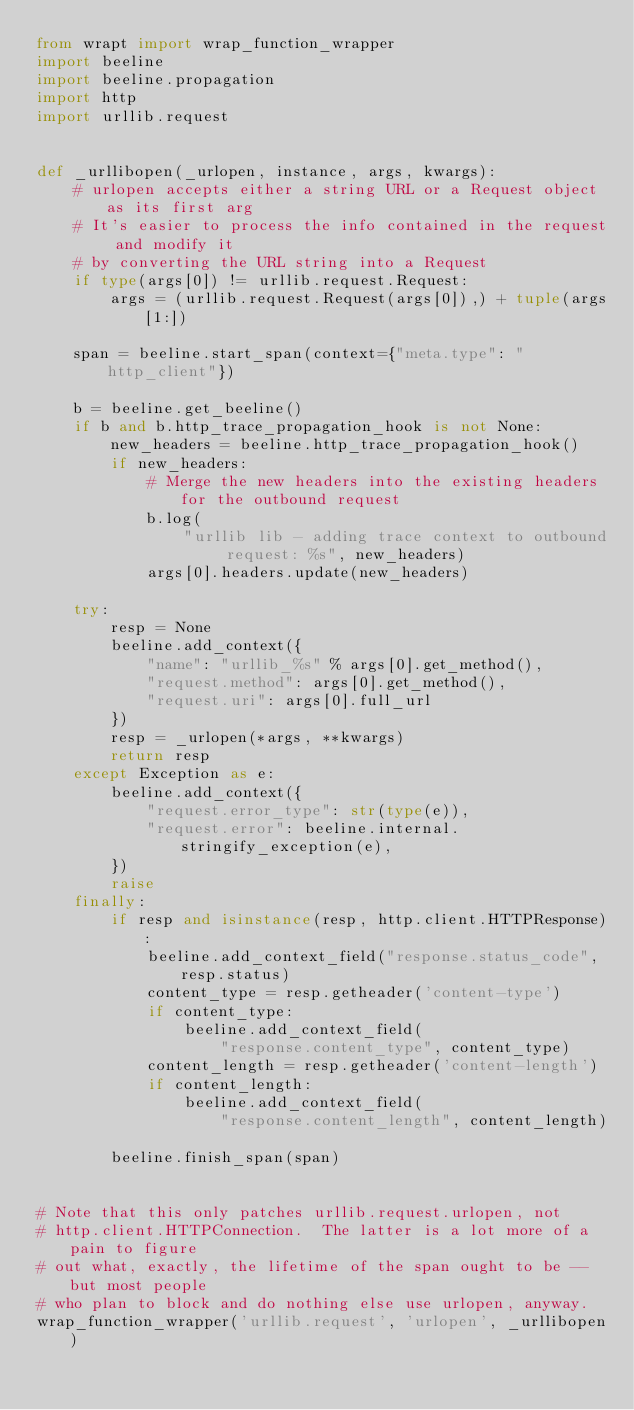Convert code to text. <code><loc_0><loc_0><loc_500><loc_500><_Python_>from wrapt import wrap_function_wrapper
import beeline
import beeline.propagation
import http
import urllib.request


def _urllibopen(_urlopen, instance, args, kwargs):
    # urlopen accepts either a string URL or a Request object as its first arg
    # It's easier to process the info contained in the request and modify it
    # by converting the URL string into a Request
    if type(args[0]) != urllib.request.Request:
        args = (urllib.request.Request(args[0]),) + tuple(args[1:])

    span = beeline.start_span(context={"meta.type": "http_client"})

    b = beeline.get_beeline()
    if b and b.http_trace_propagation_hook is not None:
        new_headers = beeline.http_trace_propagation_hook()
        if new_headers:
            # Merge the new headers into the existing headers for the outbound request
            b.log(
                "urllib lib - adding trace context to outbound request: %s", new_headers)
            args[0].headers.update(new_headers)

    try:
        resp = None
        beeline.add_context({
            "name": "urllib_%s" % args[0].get_method(),
            "request.method": args[0].get_method(),
            "request.uri": args[0].full_url
        })
        resp = _urlopen(*args, **kwargs)
        return resp
    except Exception as e:
        beeline.add_context({
            "request.error_type": str(type(e)),
            "request.error": beeline.internal.stringify_exception(e),
        })
        raise
    finally:
        if resp and isinstance(resp, http.client.HTTPResponse):
            beeline.add_context_field("response.status_code", resp.status)
            content_type = resp.getheader('content-type')
            if content_type:
                beeline.add_context_field(
                    "response.content_type", content_type)
            content_length = resp.getheader('content-length')
            if content_length:
                beeline.add_context_field(
                    "response.content_length", content_length)

        beeline.finish_span(span)


# Note that this only patches urllib.request.urlopen, not
# http.client.HTTPConnection.  The latter is a lot more of a pain to figure
# out what, exactly, the lifetime of the span ought to be -- but most people
# who plan to block and do nothing else use urlopen, anyway.
wrap_function_wrapper('urllib.request', 'urlopen', _urllibopen)
</code> 